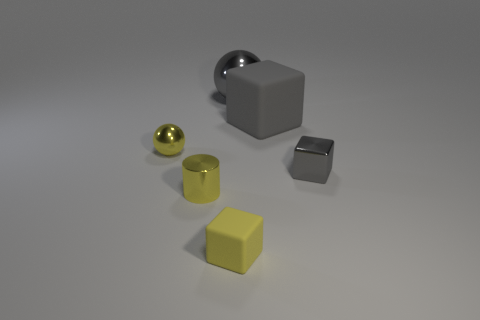There is a tiny object that is the same color as the big cube; what is its shape?
Keep it short and to the point. Cube. The small metallic cylinder has what color?
Give a very brief answer. Yellow. Are there any balls on the left side of the small yellow shiny thing that is left of the yellow metal cylinder?
Give a very brief answer. No. What number of yellow matte things are the same size as the cylinder?
Make the answer very short. 1. How many small balls are behind the sphere in front of the rubber cube behind the yellow cube?
Your answer should be compact. 0. How many tiny shiny objects are on the left side of the yellow metallic cylinder and right of the yellow block?
Your answer should be compact. 0. Is there anything else that is the same color as the metallic cylinder?
Make the answer very short. Yes. What number of rubber things are cylinders or cubes?
Provide a short and direct response. 2. What material is the big gray thing that is in front of the big gray object that is behind the matte block that is behind the tiny matte thing made of?
Provide a short and direct response. Rubber. The tiny object right of the shiny ball to the right of the yellow block is made of what material?
Provide a short and direct response. Metal. 